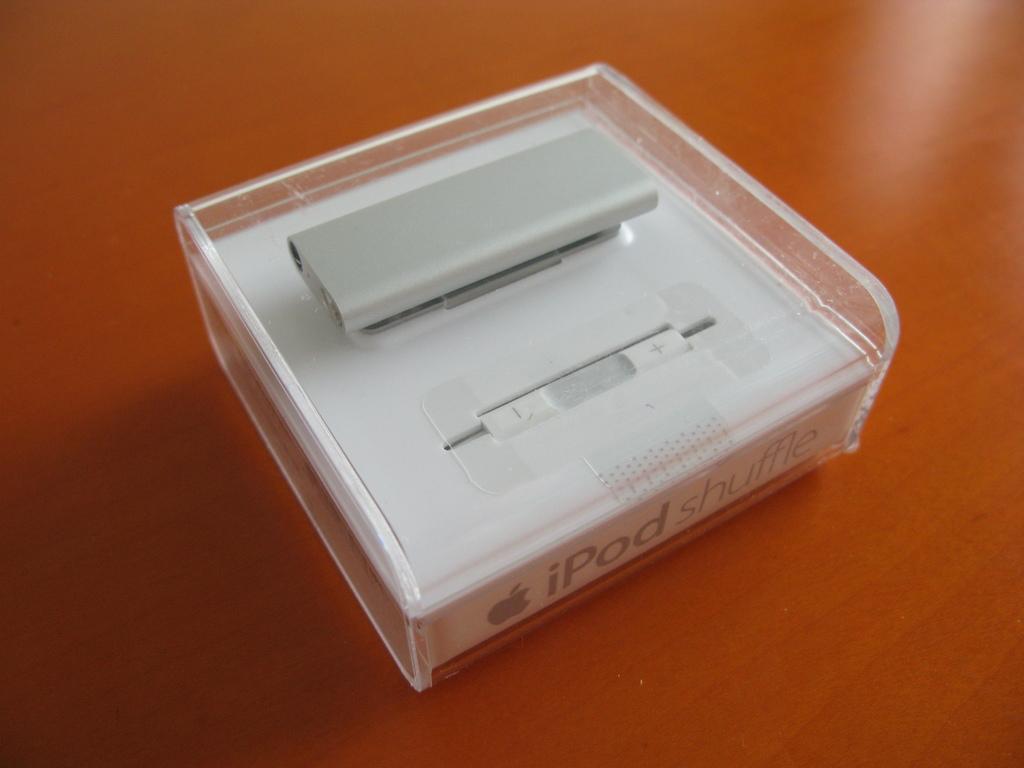What kind of ipod is this?
Keep it short and to the point. Shuffle. What brand is this?
Provide a short and direct response. Apple. 